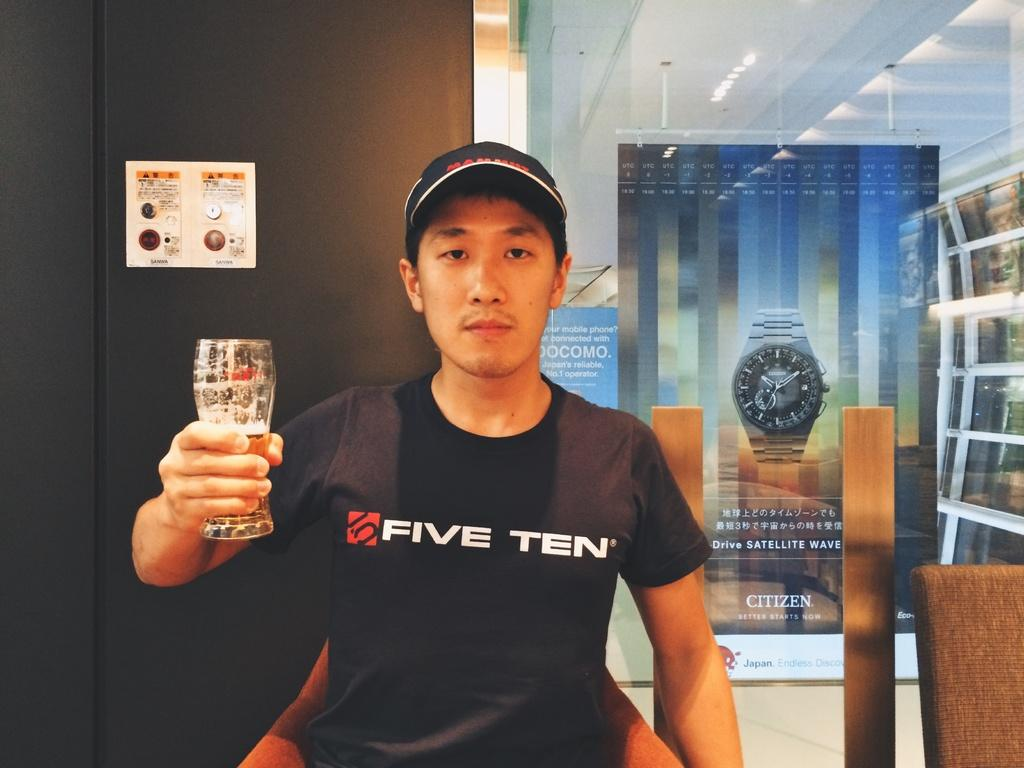<image>
Render a clear and concise summary of the photo. A man wearing a t-shirt with the word ten on it is holding a glass. 